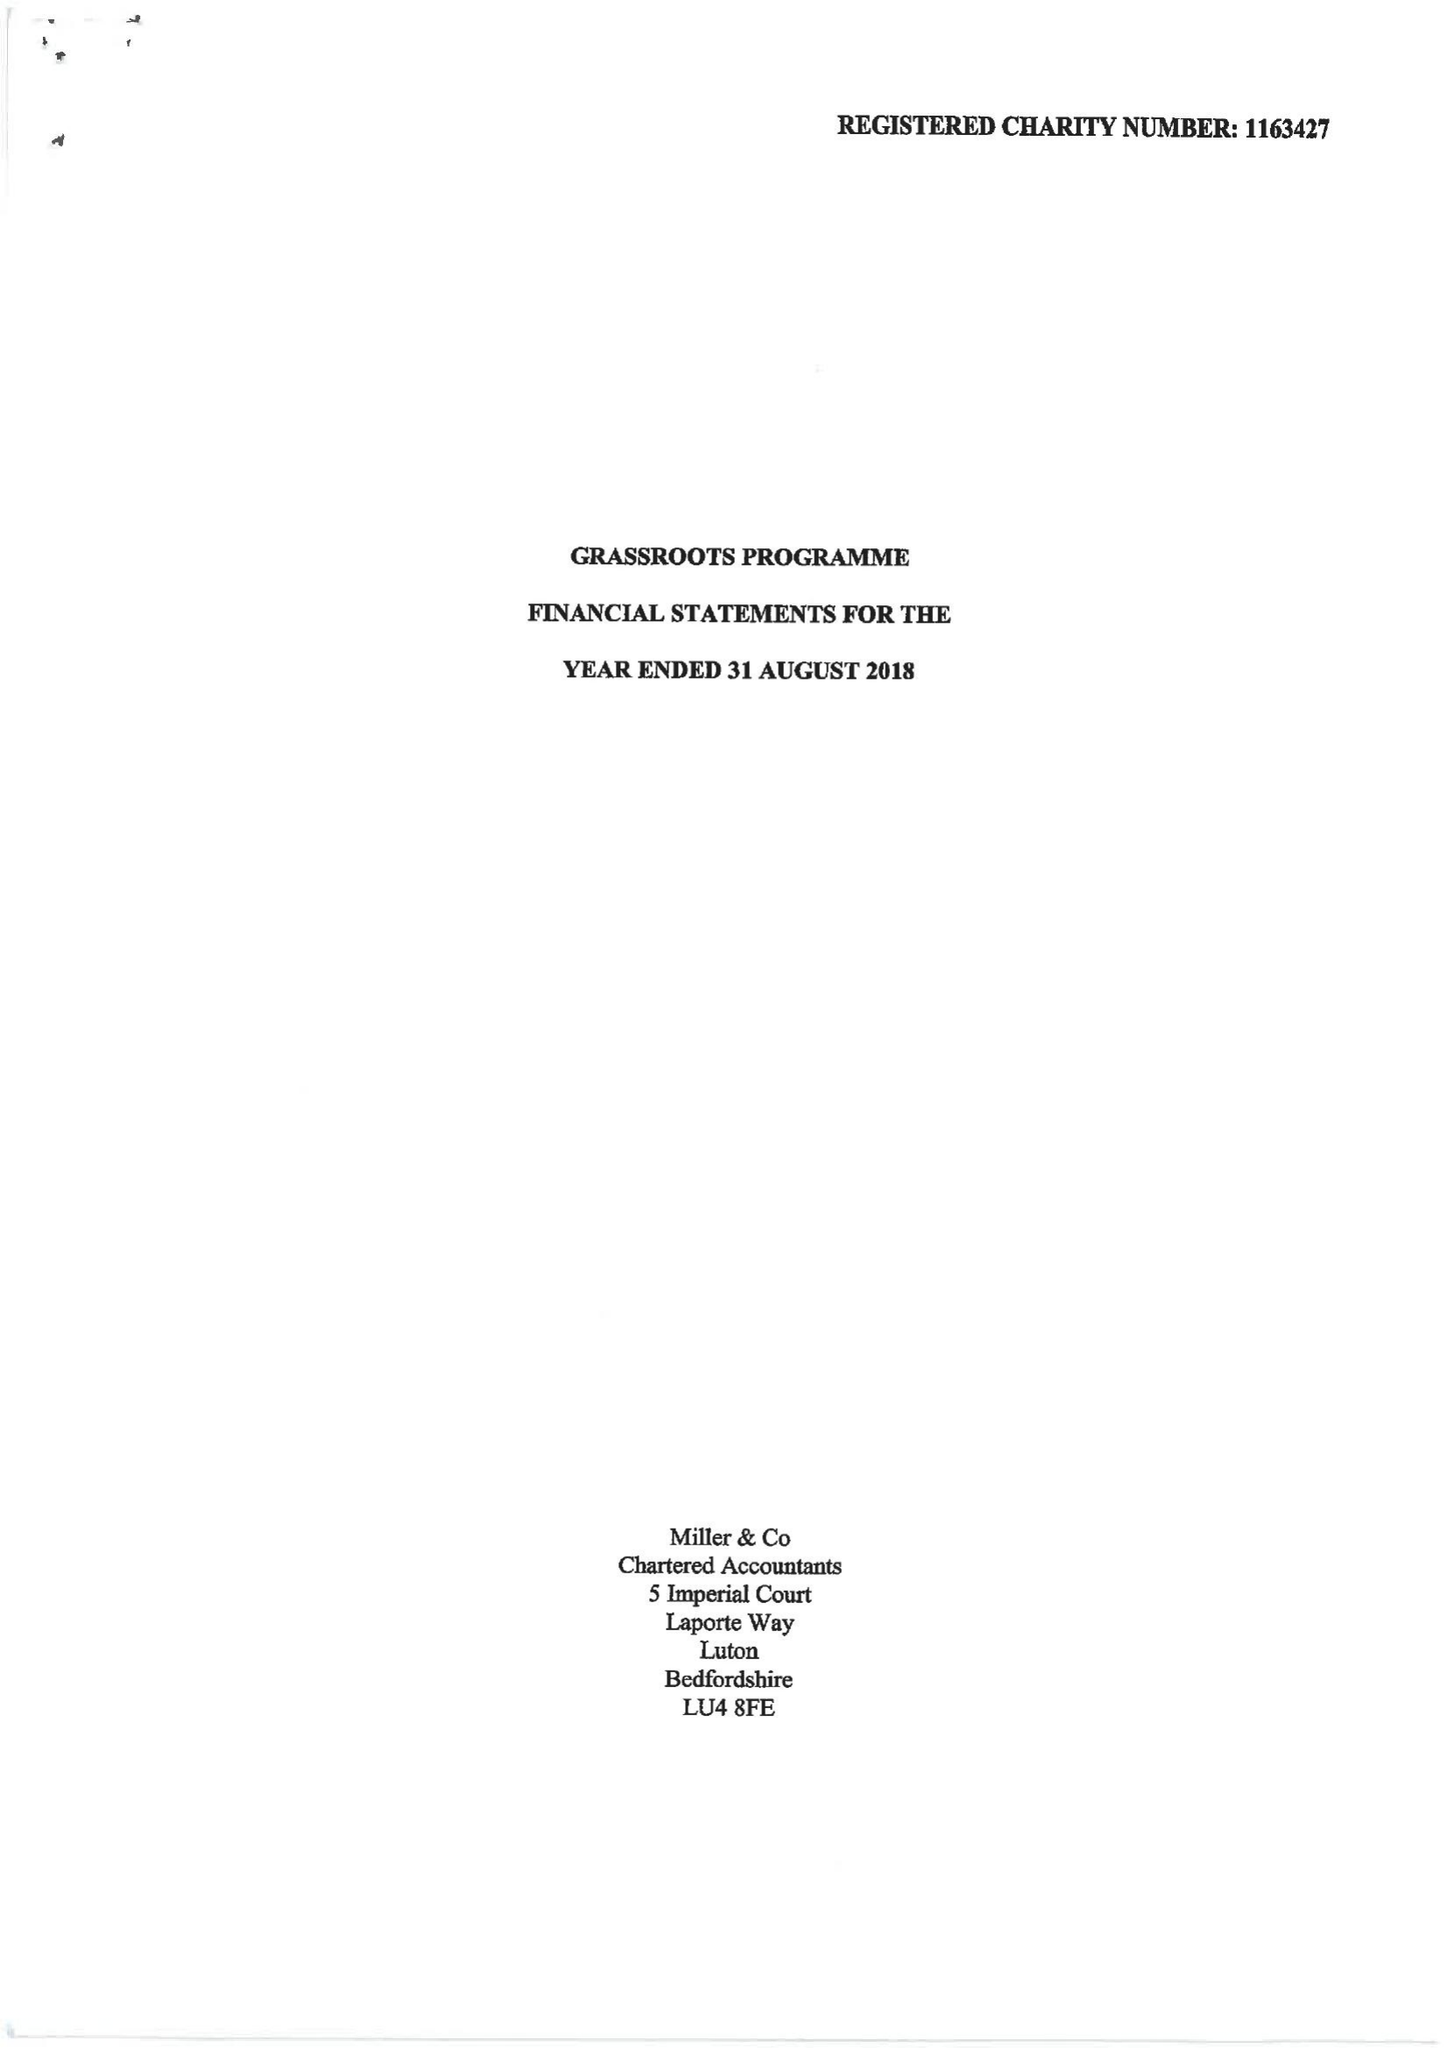What is the value for the charity_name?
Answer the question using a single word or phrase. Grassroots Programme 